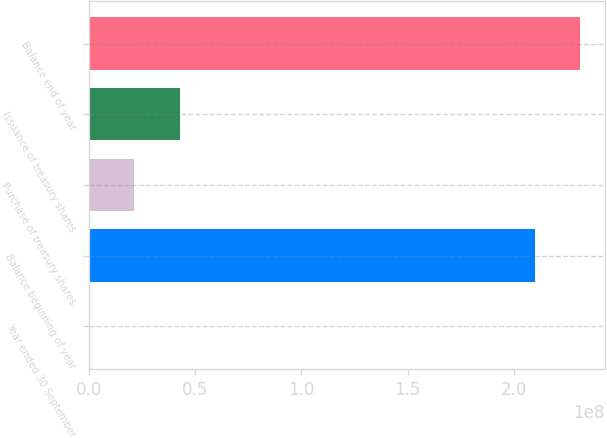Convert chart. <chart><loc_0><loc_0><loc_500><loc_500><bar_chart><fcel>Year ended 30 September<fcel>Balance beginning of year<fcel>Purchase of treasury shares<fcel>Issuance of treasury shares<fcel>Balance end of year<nl><fcel>2012<fcel>2.10185e+08<fcel>2.12494e+07<fcel>4.24968e+07<fcel>2.31433e+08<nl></chart> 